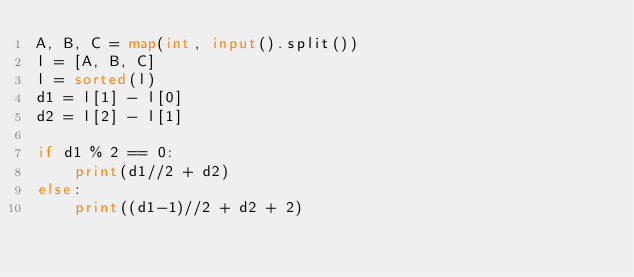<code> <loc_0><loc_0><loc_500><loc_500><_Python_>A, B, C = map(int, input().split())
l = [A, B, C]
l = sorted(l)
d1 = l[1] - l[0]
d2 = l[2] - l[1]

if d1 % 2 == 0:
    print(d1//2 + d2)
else:
    print((d1-1)//2 + d2 + 2)</code> 